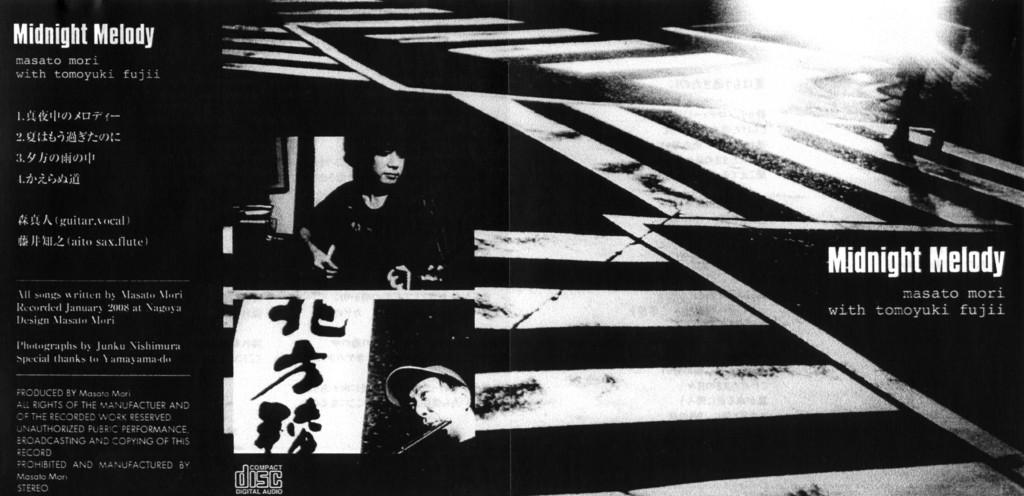<image>
Create a compact narrative representing the image presented. A black and white ad for Midnight Melody. 